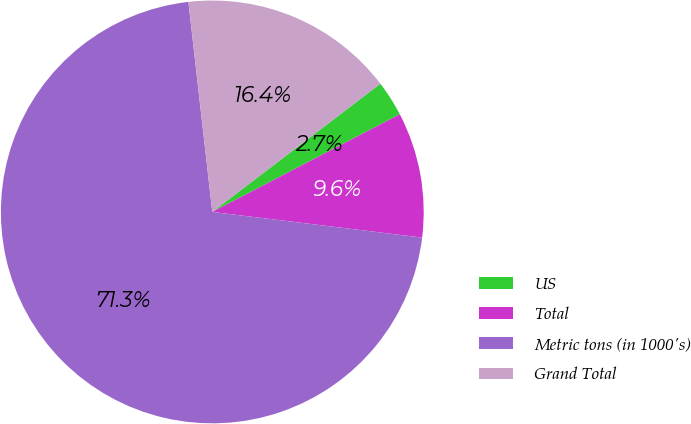Convert chart. <chart><loc_0><loc_0><loc_500><loc_500><pie_chart><fcel>US<fcel>Total<fcel>Metric tons (in 1000's)<fcel>Grand Total<nl><fcel>2.73%<fcel>9.58%<fcel>71.26%<fcel>16.43%<nl></chart> 